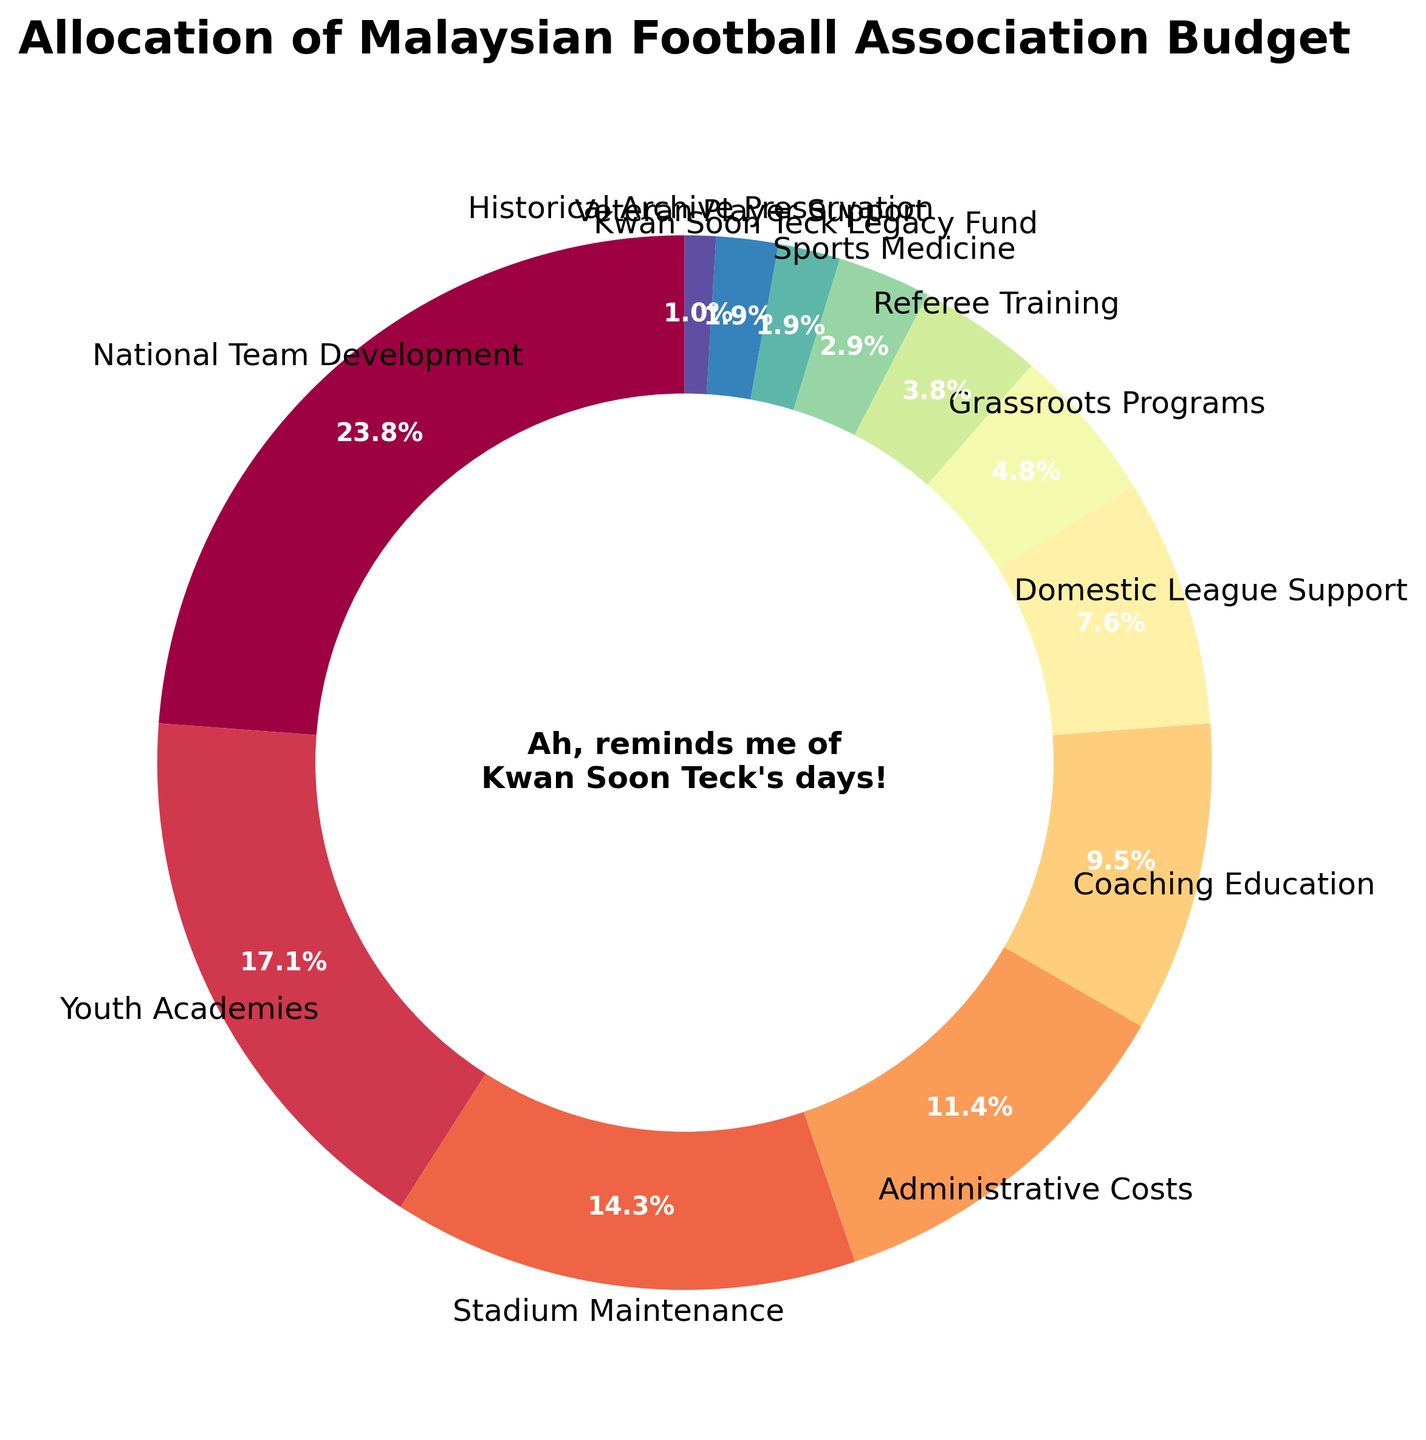Which category receives the highest percentage of the budget? First, identify and locate the segment with the largest percentage label. The "National Team Development" slice shows 25%, which is the highest allocation.
Answer: National Team Development What is the combined percentage of the "Kwan Soon Teck Legacy Fund" and "Veteran Player Support"? Look for the slices labeled "Kwan Soon Teck Legacy Fund" (2%) and "Veteran Player Support" (2%). Sum these two percentages: 2% + 2% = 4%.
Answer: 4% How does the "Youth Academies" budget compare to "Stadium Maintenance"? Find the two segments labeled "Youth Academies" (18%) and "Stadium Maintenance" (15%). Compare the values: 18% is greater than 15%.
Answer: Youth Academies receives a higher percentage Which categories get the smallest and largest percentages? Locate the slices with the largest (National Team Development - 25%) and smallest (Historical Archive Preservation - 1%) percentage labels.
Answer: National Team Development and Historical Archive Preservation What is the total percentage allocation for all the coaching and training-related categories? Sum the percentages for "Coaching Education" (10%), "Referee Training" (4%), and "Sport Medicine" (3%): 10% + 4% + 3% = 17%.
Answer: 17% Which category has a percentage allocation that is twice that of "Grassroots Programs"? Locate "Grassroots Programs" with 5%. Identify the slice with the label 10%, which matches twice the percentage: "Coaching Education".
Answer: Coaching Education If the "Administrative Costs" were increased by 5%, what would be its new percentage allocation? Find "Administrative Costs" (12%) and add 5% to it: 12% + 5% = 17%.
Answer: 17% List the categories whose allocation percentage is less than "Domestic League Support". Identify "Domestic League Support" with 8%. List segments with percentages below 8%: "Grassroots Programs" (5%), "Referee Training" (4%), "Sports Medicine" (3%), "Kwan Soon Teck Legacy Fund" (2%), "Veteran Player Support" (2%), "Historical Archive Preservation" (1%).
Answer: Grassroots Programs, Referee Training, Sports Medicine, Kwan Soon Teck Legacy Fund, Veteran Player Support, Historical Archive Preservation What is the visual color spectrum used in the pie chart? The chart uses a color gradient from the Spectral colormap, which typically includes a range of colors from red and yellow to green and blue.
Answer: Red, yellow, green, blue, etc 